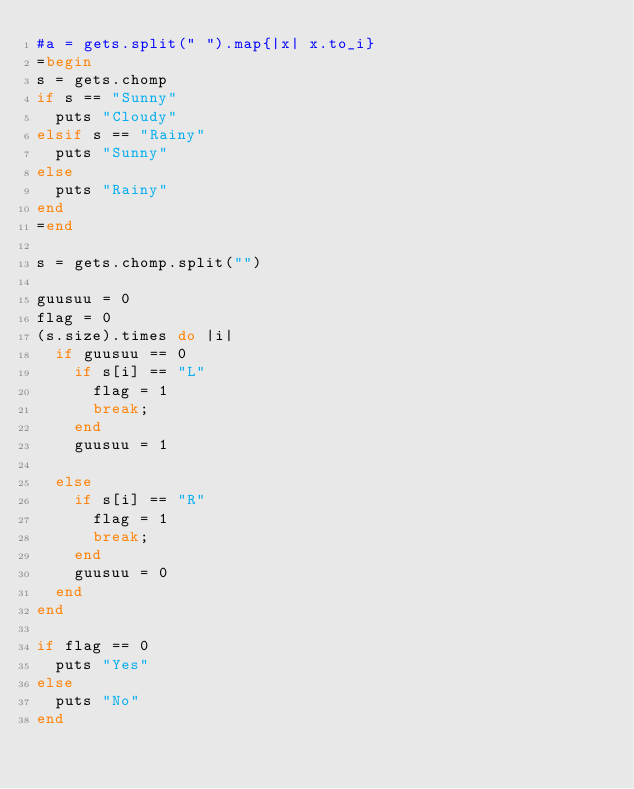<code> <loc_0><loc_0><loc_500><loc_500><_Ruby_>#a = gets.split(" ").map{|x| x.to_i}
=begin
s = gets.chomp
if s == "Sunny"
  puts "Cloudy"
elsif s == "Rainy"
  puts "Sunny"
else
  puts "Rainy"
end
=end

s = gets.chomp.split("")

guusuu = 0
flag = 0
(s.size).times do |i|
  if guusuu == 0
    if s[i] == "L"
      flag = 1
      break;
    end
    guusuu = 1

  else
    if s[i] == "R"
      flag = 1
      break;
    end
    guusuu = 0
  end
end

if flag == 0
  puts "Yes"
else
  puts "No"
end
</code> 